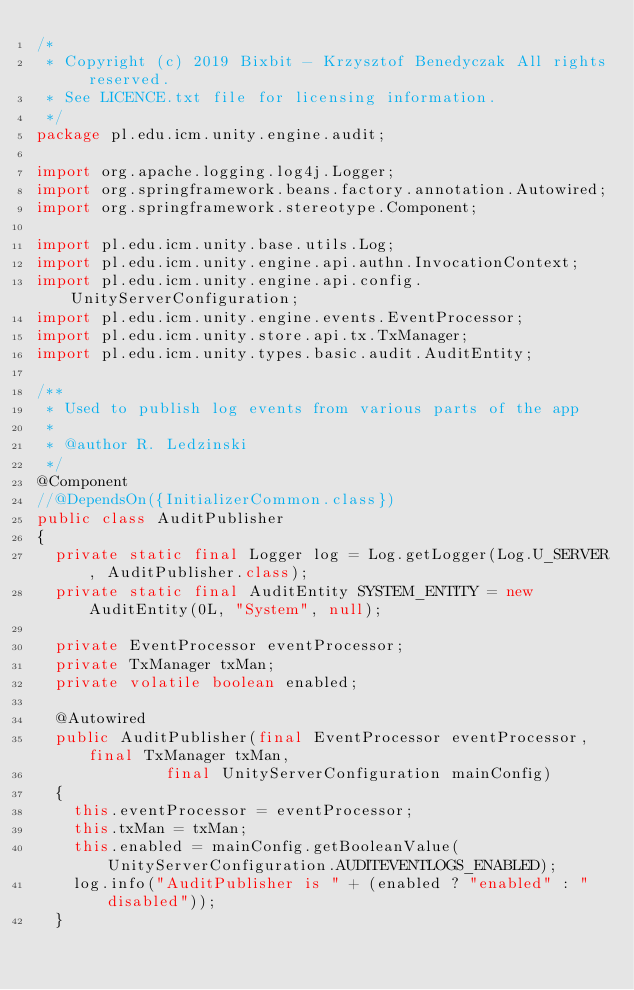Convert code to text. <code><loc_0><loc_0><loc_500><loc_500><_Java_>/*
 * Copyright (c) 2019 Bixbit - Krzysztof Benedyczak All rights reserved.
 * See LICENCE.txt file for licensing information.
 */
package pl.edu.icm.unity.engine.audit;

import org.apache.logging.log4j.Logger;
import org.springframework.beans.factory.annotation.Autowired;
import org.springframework.stereotype.Component;

import pl.edu.icm.unity.base.utils.Log;
import pl.edu.icm.unity.engine.api.authn.InvocationContext;
import pl.edu.icm.unity.engine.api.config.UnityServerConfiguration;
import pl.edu.icm.unity.engine.events.EventProcessor;
import pl.edu.icm.unity.store.api.tx.TxManager;
import pl.edu.icm.unity.types.basic.audit.AuditEntity;

/**
 * Used to publish log events from various parts of the app
 *
 * @author R. Ledzinski
 */
@Component
//@DependsOn({InitializerCommon.class})
public class AuditPublisher
{
	private static final Logger log = Log.getLogger(Log.U_SERVER, AuditPublisher.class);
	private static final AuditEntity SYSTEM_ENTITY = new AuditEntity(0L, "System", null);

	private EventProcessor eventProcessor;
	private TxManager txMan;
	private volatile boolean enabled;

	@Autowired
	public AuditPublisher(final EventProcessor eventProcessor, final TxManager txMan,
						  final UnityServerConfiguration mainConfig)
	{
		this.eventProcessor = eventProcessor;
		this.txMan = txMan;
		this.enabled = mainConfig.getBooleanValue(UnityServerConfiguration.AUDITEVENTLOGS_ENABLED);
		log.info("AuditPublisher is " + (enabled ? "enabled" : "disabled"));
	}
</code> 